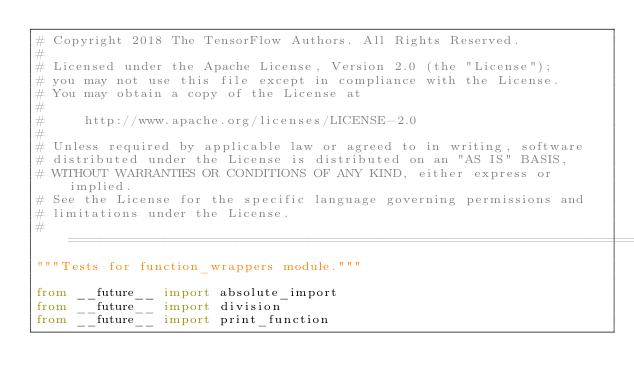<code> <loc_0><loc_0><loc_500><loc_500><_Python_># Copyright 2018 The TensorFlow Authors. All Rights Reserved.
#
# Licensed under the Apache License, Version 2.0 (the "License");
# you may not use this file except in compliance with the License.
# You may obtain a copy of the License at
#
#     http://www.apache.org/licenses/LICENSE-2.0
#
# Unless required by applicable law or agreed to in writing, software
# distributed under the License is distributed on an "AS IS" BASIS,
# WITHOUT WARRANTIES OR CONDITIONS OF ANY KIND, either express or implied.
# See the License for the specific language governing permissions and
# limitations under the License.
# ==============================================================================
"""Tests for function_wrappers module."""

from __future__ import absolute_import
from __future__ import division
from __future__ import print_function
</code> 